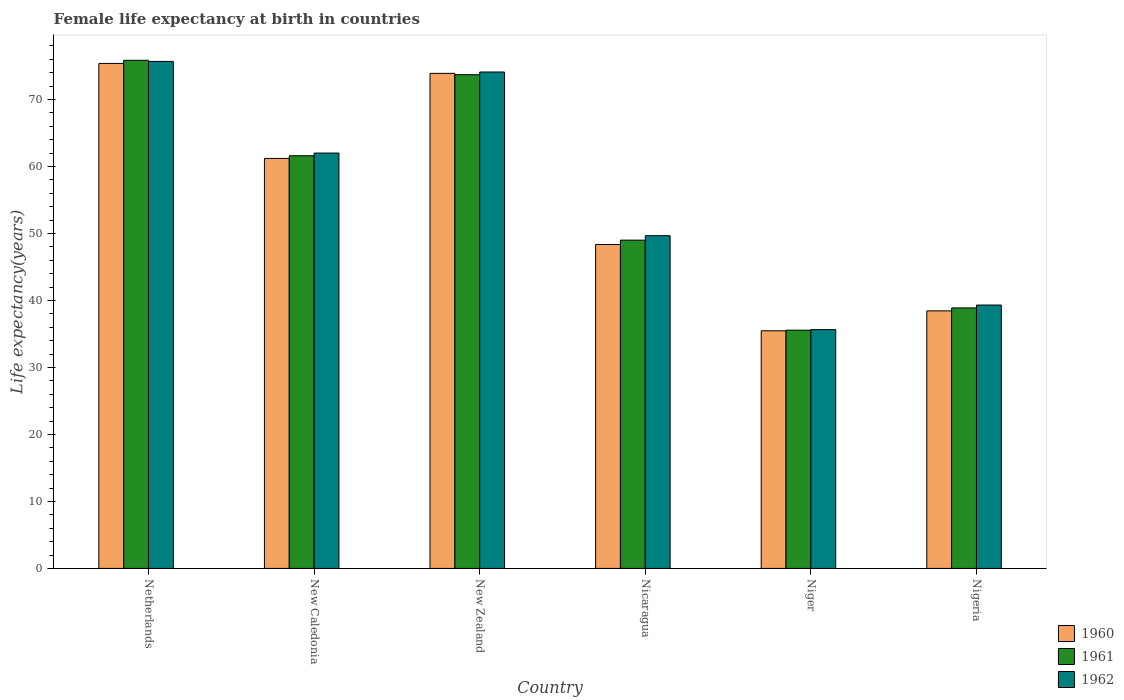How many different coloured bars are there?
Keep it short and to the point. 3. How many groups of bars are there?
Your answer should be compact. 6. How many bars are there on the 6th tick from the right?
Provide a short and direct response. 3. What is the label of the 3rd group of bars from the left?
Provide a succinct answer. New Zealand. What is the female life expectancy at birth in 1960 in Netherlands?
Your answer should be very brief. 75.38. Across all countries, what is the maximum female life expectancy at birth in 1960?
Your answer should be very brief. 75.38. Across all countries, what is the minimum female life expectancy at birth in 1962?
Offer a very short reply. 35.65. In which country was the female life expectancy at birth in 1961 minimum?
Your answer should be very brief. Niger. What is the total female life expectancy at birth in 1962 in the graph?
Offer a terse response. 336.41. What is the difference between the female life expectancy at birth in 1961 in Niger and that in Nigeria?
Provide a succinct answer. -3.33. What is the difference between the female life expectancy at birth in 1961 in Netherlands and the female life expectancy at birth in 1962 in New Caledonia?
Your response must be concise. 13.85. What is the average female life expectancy at birth in 1960 per country?
Your answer should be compact. 55.46. What is the difference between the female life expectancy at birth of/in 1961 and female life expectancy at birth of/in 1960 in New Caledonia?
Your response must be concise. 0.4. In how many countries, is the female life expectancy at birth in 1962 greater than 6 years?
Offer a very short reply. 6. What is the ratio of the female life expectancy at birth in 1962 in Netherlands to that in Nicaragua?
Provide a succinct answer. 1.52. Is the female life expectancy at birth in 1961 in Netherlands less than that in Niger?
Keep it short and to the point. No. Is the difference between the female life expectancy at birth in 1961 in New Zealand and Nigeria greater than the difference between the female life expectancy at birth in 1960 in New Zealand and Nigeria?
Your answer should be very brief. No. What is the difference between the highest and the second highest female life expectancy at birth in 1962?
Provide a succinct answer. -1.58. What is the difference between the highest and the lowest female life expectancy at birth in 1962?
Make the answer very short. 40.03. What does the 2nd bar from the left in Nigeria represents?
Your answer should be very brief. 1961. What does the 1st bar from the right in New Zealand represents?
Provide a succinct answer. 1962. Is it the case that in every country, the sum of the female life expectancy at birth in 1961 and female life expectancy at birth in 1960 is greater than the female life expectancy at birth in 1962?
Provide a succinct answer. Yes. Are all the bars in the graph horizontal?
Your answer should be very brief. No. How many countries are there in the graph?
Offer a very short reply. 6. Are the values on the major ticks of Y-axis written in scientific E-notation?
Keep it short and to the point. No. Does the graph contain any zero values?
Keep it short and to the point. No. How many legend labels are there?
Your answer should be compact. 3. How are the legend labels stacked?
Ensure brevity in your answer.  Vertical. What is the title of the graph?
Provide a short and direct response. Female life expectancy at birth in countries. Does "1989" appear as one of the legend labels in the graph?
Your response must be concise. No. What is the label or title of the Y-axis?
Offer a very short reply. Life expectancy(years). What is the Life expectancy(years) of 1960 in Netherlands?
Ensure brevity in your answer.  75.38. What is the Life expectancy(years) in 1961 in Netherlands?
Provide a succinct answer. 75.85. What is the Life expectancy(years) of 1962 in Netherlands?
Keep it short and to the point. 75.68. What is the Life expectancy(years) in 1960 in New Caledonia?
Your response must be concise. 61.2. What is the Life expectancy(years) of 1961 in New Caledonia?
Your response must be concise. 61.6. What is the Life expectancy(years) in 1962 in New Caledonia?
Offer a very short reply. 62. What is the Life expectancy(years) in 1960 in New Zealand?
Keep it short and to the point. 73.9. What is the Life expectancy(years) in 1961 in New Zealand?
Your answer should be compact. 73.7. What is the Life expectancy(years) of 1962 in New Zealand?
Offer a very short reply. 74.1. What is the Life expectancy(years) in 1960 in Nicaragua?
Your answer should be very brief. 48.35. What is the Life expectancy(years) of 1961 in Nicaragua?
Offer a terse response. 49. What is the Life expectancy(years) in 1962 in Nicaragua?
Ensure brevity in your answer.  49.67. What is the Life expectancy(years) of 1960 in Niger?
Provide a short and direct response. 35.47. What is the Life expectancy(years) in 1961 in Niger?
Offer a very short reply. 35.56. What is the Life expectancy(years) in 1962 in Niger?
Offer a terse response. 35.65. What is the Life expectancy(years) in 1960 in Nigeria?
Offer a very short reply. 38.45. What is the Life expectancy(years) of 1961 in Nigeria?
Your response must be concise. 38.89. What is the Life expectancy(years) in 1962 in Nigeria?
Offer a very short reply. 39.31. Across all countries, what is the maximum Life expectancy(years) of 1960?
Provide a succinct answer. 75.38. Across all countries, what is the maximum Life expectancy(years) in 1961?
Your response must be concise. 75.85. Across all countries, what is the maximum Life expectancy(years) of 1962?
Offer a terse response. 75.68. Across all countries, what is the minimum Life expectancy(years) in 1960?
Keep it short and to the point. 35.47. Across all countries, what is the minimum Life expectancy(years) in 1961?
Make the answer very short. 35.56. Across all countries, what is the minimum Life expectancy(years) in 1962?
Your response must be concise. 35.65. What is the total Life expectancy(years) of 1960 in the graph?
Keep it short and to the point. 332.75. What is the total Life expectancy(years) in 1961 in the graph?
Your answer should be very brief. 334.6. What is the total Life expectancy(years) of 1962 in the graph?
Provide a short and direct response. 336.41. What is the difference between the Life expectancy(years) of 1960 in Netherlands and that in New Caledonia?
Your response must be concise. 14.18. What is the difference between the Life expectancy(years) in 1961 in Netherlands and that in New Caledonia?
Ensure brevity in your answer.  14.25. What is the difference between the Life expectancy(years) of 1962 in Netherlands and that in New Caledonia?
Provide a succinct answer. 13.68. What is the difference between the Life expectancy(years) in 1960 in Netherlands and that in New Zealand?
Give a very brief answer. 1.48. What is the difference between the Life expectancy(years) of 1961 in Netherlands and that in New Zealand?
Offer a terse response. 2.15. What is the difference between the Life expectancy(years) of 1962 in Netherlands and that in New Zealand?
Your answer should be compact. 1.58. What is the difference between the Life expectancy(years) in 1960 in Netherlands and that in Nicaragua?
Offer a very short reply. 27.03. What is the difference between the Life expectancy(years) in 1961 in Netherlands and that in Nicaragua?
Keep it short and to the point. 26.85. What is the difference between the Life expectancy(years) in 1962 in Netherlands and that in Nicaragua?
Provide a succinct answer. 26.01. What is the difference between the Life expectancy(years) in 1960 in Netherlands and that in Niger?
Keep it short and to the point. 39.91. What is the difference between the Life expectancy(years) of 1961 in Netherlands and that in Niger?
Keep it short and to the point. 40.29. What is the difference between the Life expectancy(years) in 1962 in Netherlands and that in Niger?
Keep it short and to the point. 40.03. What is the difference between the Life expectancy(years) of 1960 in Netherlands and that in Nigeria?
Keep it short and to the point. 36.94. What is the difference between the Life expectancy(years) of 1961 in Netherlands and that in Nigeria?
Your answer should be very brief. 36.96. What is the difference between the Life expectancy(years) in 1962 in Netherlands and that in Nigeria?
Give a very brief answer. 36.37. What is the difference between the Life expectancy(years) in 1961 in New Caledonia and that in New Zealand?
Make the answer very short. -12.1. What is the difference between the Life expectancy(years) in 1962 in New Caledonia and that in New Zealand?
Your answer should be compact. -12.1. What is the difference between the Life expectancy(years) of 1960 in New Caledonia and that in Nicaragua?
Make the answer very short. 12.85. What is the difference between the Life expectancy(years) of 1961 in New Caledonia and that in Nicaragua?
Offer a very short reply. 12.6. What is the difference between the Life expectancy(years) of 1962 in New Caledonia and that in Nicaragua?
Your answer should be very brief. 12.33. What is the difference between the Life expectancy(years) of 1960 in New Caledonia and that in Niger?
Offer a very short reply. 25.73. What is the difference between the Life expectancy(years) in 1961 in New Caledonia and that in Niger?
Make the answer very short. 26.04. What is the difference between the Life expectancy(years) in 1962 in New Caledonia and that in Niger?
Provide a short and direct response. 26.35. What is the difference between the Life expectancy(years) in 1960 in New Caledonia and that in Nigeria?
Provide a short and direct response. 22.75. What is the difference between the Life expectancy(years) in 1961 in New Caledonia and that in Nigeria?
Provide a succinct answer. 22.71. What is the difference between the Life expectancy(years) of 1962 in New Caledonia and that in Nigeria?
Make the answer very short. 22.68. What is the difference between the Life expectancy(years) in 1960 in New Zealand and that in Nicaragua?
Provide a succinct answer. 25.55. What is the difference between the Life expectancy(years) in 1961 in New Zealand and that in Nicaragua?
Your answer should be very brief. 24.7. What is the difference between the Life expectancy(years) in 1962 in New Zealand and that in Nicaragua?
Your answer should be compact. 24.43. What is the difference between the Life expectancy(years) in 1960 in New Zealand and that in Niger?
Your response must be concise. 38.43. What is the difference between the Life expectancy(years) in 1961 in New Zealand and that in Niger?
Ensure brevity in your answer.  38.14. What is the difference between the Life expectancy(years) of 1962 in New Zealand and that in Niger?
Offer a very short reply. 38.45. What is the difference between the Life expectancy(years) in 1960 in New Zealand and that in Nigeria?
Keep it short and to the point. 35.45. What is the difference between the Life expectancy(years) in 1961 in New Zealand and that in Nigeria?
Your response must be concise. 34.81. What is the difference between the Life expectancy(years) in 1962 in New Zealand and that in Nigeria?
Provide a short and direct response. 34.78. What is the difference between the Life expectancy(years) in 1960 in Nicaragua and that in Niger?
Offer a terse response. 12.88. What is the difference between the Life expectancy(years) in 1961 in Nicaragua and that in Niger?
Provide a succinct answer. 13.44. What is the difference between the Life expectancy(years) of 1962 in Nicaragua and that in Niger?
Make the answer very short. 14.02. What is the difference between the Life expectancy(years) in 1960 in Nicaragua and that in Nigeria?
Your answer should be compact. 9.9. What is the difference between the Life expectancy(years) in 1961 in Nicaragua and that in Nigeria?
Ensure brevity in your answer.  10.12. What is the difference between the Life expectancy(years) in 1962 in Nicaragua and that in Nigeria?
Offer a very short reply. 10.35. What is the difference between the Life expectancy(years) of 1960 in Niger and that in Nigeria?
Your answer should be compact. -2.97. What is the difference between the Life expectancy(years) of 1961 in Niger and that in Nigeria?
Offer a terse response. -3.33. What is the difference between the Life expectancy(years) of 1962 in Niger and that in Nigeria?
Your response must be concise. -3.67. What is the difference between the Life expectancy(years) in 1960 in Netherlands and the Life expectancy(years) in 1961 in New Caledonia?
Keep it short and to the point. 13.78. What is the difference between the Life expectancy(years) of 1960 in Netherlands and the Life expectancy(years) of 1962 in New Caledonia?
Provide a succinct answer. 13.38. What is the difference between the Life expectancy(years) in 1961 in Netherlands and the Life expectancy(years) in 1962 in New Caledonia?
Give a very brief answer. 13.85. What is the difference between the Life expectancy(years) in 1960 in Netherlands and the Life expectancy(years) in 1961 in New Zealand?
Your response must be concise. 1.68. What is the difference between the Life expectancy(years) in 1960 in Netherlands and the Life expectancy(years) in 1962 in New Zealand?
Make the answer very short. 1.28. What is the difference between the Life expectancy(years) of 1961 in Netherlands and the Life expectancy(years) of 1962 in New Zealand?
Make the answer very short. 1.75. What is the difference between the Life expectancy(years) of 1960 in Netherlands and the Life expectancy(years) of 1961 in Nicaragua?
Keep it short and to the point. 26.38. What is the difference between the Life expectancy(years) in 1960 in Netherlands and the Life expectancy(years) in 1962 in Nicaragua?
Your response must be concise. 25.71. What is the difference between the Life expectancy(years) in 1961 in Netherlands and the Life expectancy(years) in 1962 in Nicaragua?
Your answer should be compact. 26.18. What is the difference between the Life expectancy(years) in 1960 in Netherlands and the Life expectancy(years) in 1961 in Niger?
Keep it short and to the point. 39.82. What is the difference between the Life expectancy(years) in 1960 in Netherlands and the Life expectancy(years) in 1962 in Niger?
Your response must be concise. 39.73. What is the difference between the Life expectancy(years) of 1961 in Netherlands and the Life expectancy(years) of 1962 in Niger?
Your answer should be compact. 40.2. What is the difference between the Life expectancy(years) in 1960 in Netherlands and the Life expectancy(years) in 1961 in Nigeria?
Make the answer very short. 36.49. What is the difference between the Life expectancy(years) of 1960 in Netherlands and the Life expectancy(years) of 1962 in Nigeria?
Ensure brevity in your answer.  36.06. What is the difference between the Life expectancy(years) of 1961 in Netherlands and the Life expectancy(years) of 1962 in Nigeria?
Your answer should be compact. 36.53. What is the difference between the Life expectancy(years) in 1960 in New Caledonia and the Life expectancy(years) in 1961 in New Zealand?
Give a very brief answer. -12.5. What is the difference between the Life expectancy(years) of 1961 in New Caledonia and the Life expectancy(years) of 1962 in New Zealand?
Provide a short and direct response. -12.5. What is the difference between the Life expectancy(years) of 1960 in New Caledonia and the Life expectancy(years) of 1961 in Nicaragua?
Your answer should be very brief. 12.2. What is the difference between the Life expectancy(years) of 1960 in New Caledonia and the Life expectancy(years) of 1962 in Nicaragua?
Ensure brevity in your answer.  11.53. What is the difference between the Life expectancy(years) of 1961 in New Caledonia and the Life expectancy(years) of 1962 in Nicaragua?
Provide a succinct answer. 11.93. What is the difference between the Life expectancy(years) of 1960 in New Caledonia and the Life expectancy(years) of 1961 in Niger?
Give a very brief answer. 25.64. What is the difference between the Life expectancy(years) in 1960 in New Caledonia and the Life expectancy(years) in 1962 in Niger?
Give a very brief answer. 25.55. What is the difference between the Life expectancy(years) of 1961 in New Caledonia and the Life expectancy(years) of 1962 in Niger?
Ensure brevity in your answer.  25.95. What is the difference between the Life expectancy(years) of 1960 in New Caledonia and the Life expectancy(years) of 1961 in Nigeria?
Offer a very short reply. 22.31. What is the difference between the Life expectancy(years) in 1960 in New Caledonia and the Life expectancy(years) in 1962 in Nigeria?
Make the answer very short. 21.89. What is the difference between the Life expectancy(years) in 1961 in New Caledonia and the Life expectancy(years) in 1962 in Nigeria?
Provide a succinct answer. 22.29. What is the difference between the Life expectancy(years) of 1960 in New Zealand and the Life expectancy(years) of 1961 in Nicaragua?
Make the answer very short. 24.9. What is the difference between the Life expectancy(years) of 1960 in New Zealand and the Life expectancy(years) of 1962 in Nicaragua?
Ensure brevity in your answer.  24.23. What is the difference between the Life expectancy(years) in 1961 in New Zealand and the Life expectancy(years) in 1962 in Nicaragua?
Ensure brevity in your answer.  24.03. What is the difference between the Life expectancy(years) in 1960 in New Zealand and the Life expectancy(years) in 1961 in Niger?
Provide a succinct answer. 38.34. What is the difference between the Life expectancy(years) of 1960 in New Zealand and the Life expectancy(years) of 1962 in Niger?
Provide a short and direct response. 38.25. What is the difference between the Life expectancy(years) in 1961 in New Zealand and the Life expectancy(years) in 1962 in Niger?
Offer a very short reply. 38.05. What is the difference between the Life expectancy(years) in 1960 in New Zealand and the Life expectancy(years) in 1961 in Nigeria?
Keep it short and to the point. 35.01. What is the difference between the Life expectancy(years) in 1960 in New Zealand and the Life expectancy(years) in 1962 in Nigeria?
Your answer should be compact. 34.59. What is the difference between the Life expectancy(years) of 1961 in New Zealand and the Life expectancy(years) of 1962 in Nigeria?
Offer a terse response. 34.38. What is the difference between the Life expectancy(years) of 1960 in Nicaragua and the Life expectancy(years) of 1961 in Niger?
Offer a terse response. 12.79. What is the difference between the Life expectancy(years) of 1960 in Nicaragua and the Life expectancy(years) of 1962 in Niger?
Make the answer very short. 12.7. What is the difference between the Life expectancy(years) in 1961 in Nicaragua and the Life expectancy(years) in 1962 in Niger?
Give a very brief answer. 13.36. What is the difference between the Life expectancy(years) of 1960 in Nicaragua and the Life expectancy(years) of 1961 in Nigeria?
Your response must be concise. 9.46. What is the difference between the Life expectancy(years) of 1960 in Nicaragua and the Life expectancy(years) of 1962 in Nigeria?
Provide a short and direct response. 9.04. What is the difference between the Life expectancy(years) in 1961 in Nicaragua and the Life expectancy(years) in 1962 in Nigeria?
Your answer should be very brief. 9.69. What is the difference between the Life expectancy(years) in 1960 in Niger and the Life expectancy(years) in 1961 in Nigeria?
Your response must be concise. -3.42. What is the difference between the Life expectancy(years) in 1960 in Niger and the Life expectancy(years) in 1962 in Nigeria?
Offer a terse response. -3.84. What is the difference between the Life expectancy(years) in 1961 in Niger and the Life expectancy(years) in 1962 in Nigeria?
Ensure brevity in your answer.  -3.75. What is the average Life expectancy(years) of 1960 per country?
Your answer should be compact. 55.46. What is the average Life expectancy(years) in 1961 per country?
Ensure brevity in your answer.  55.77. What is the average Life expectancy(years) of 1962 per country?
Your response must be concise. 56.07. What is the difference between the Life expectancy(years) of 1960 and Life expectancy(years) of 1961 in Netherlands?
Offer a terse response. -0.47. What is the difference between the Life expectancy(years) of 1960 and Life expectancy(years) of 1962 in Netherlands?
Offer a terse response. -0.3. What is the difference between the Life expectancy(years) of 1961 and Life expectancy(years) of 1962 in Netherlands?
Your answer should be compact. 0.17. What is the difference between the Life expectancy(years) of 1960 and Life expectancy(years) of 1961 in New Caledonia?
Ensure brevity in your answer.  -0.4. What is the difference between the Life expectancy(years) in 1960 and Life expectancy(years) in 1962 in New Zealand?
Offer a very short reply. -0.2. What is the difference between the Life expectancy(years) of 1960 and Life expectancy(years) of 1961 in Nicaragua?
Offer a terse response. -0.65. What is the difference between the Life expectancy(years) in 1960 and Life expectancy(years) in 1962 in Nicaragua?
Your response must be concise. -1.32. What is the difference between the Life expectancy(years) in 1961 and Life expectancy(years) in 1962 in Nicaragua?
Offer a very short reply. -0.66. What is the difference between the Life expectancy(years) in 1960 and Life expectancy(years) in 1961 in Niger?
Provide a short and direct response. -0.09. What is the difference between the Life expectancy(years) in 1960 and Life expectancy(years) in 1962 in Niger?
Provide a succinct answer. -0.17. What is the difference between the Life expectancy(years) of 1961 and Life expectancy(years) of 1962 in Niger?
Ensure brevity in your answer.  -0.08. What is the difference between the Life expectancy(years) in 1960 and Life expectancy(years) in 1961 in Nigeria?
Make the answer very short. -0.44. What is the difference between the Life expectancy(years) in 1960 and Life expectancy(years) in 1962 in Nigeria?
Your answer should be very brief. -0.87. What is the difference between the Life expectancy(years) of 1961 and Life expectancy(years) of 1962 in Nigeria?
Provide a short and direct response. -0.43. What is the ratio of the Life expectancy(years) of 1960 in Netherlands to that in New Caledonia?
Offer a very short reply. 1.23. What is the ratio of the Life expectancy(years) of 1961 in Netherlands to that in New Caledonia?
Provide a succinct answer. 1.23. What is the ratio of the Life expectancy(years) of 1962 in Netherlands to that in New Caledonia?
Your answer should be very brief. 1.22. What is the ratio of the Life expectancy(years) in 1961 in Netherlands to that in New Zealand?
Ensure brevity in your answer.  1.03. What is the ratio of the Life expectancy(years) in 1962 in Netherlands to that in New Zealand?
Offer a terse response. 1.02. What is the ratio of the Life expectancy(years) in 1960 in Netherlands to that in Nicaragua?
Provide a short and direct response. 1.56. What is the ratio of the Life expectancy(years) in 1961 in Netherlands to that in Nicaragua?
Make the answer very short. 1.55. What is the ratio of the Life expectancy(years) of 1962 in Netherlands to that in Nicaragua?
Make the answer very short. 1.52. What is the ratio of the Life expectancy(years) in 1960 in Netherlands to that in Niger?
Your answer should be compact. 2.13. What is the ratio of the Life expectancy(years) of 1961 in Netherlands to that in Niger?
Your answer should be very brief. 2.13. What is the ratio of the Life expectancy(years) of 1962 in Netherlands to that in Niger?
Offer a very short reply. 2.12. What is the ratio of the Life expectancy(years) in 1960 in Netherlands to that in Nigeria?
Your answer should be compact. 1.96. What is the ratio of the Life expectancy(years) of 1961 in Netherlands to that in Nigeria?
Offer a very short reply. 1.95. What is the ratio of the Life expectancy(years) of 1962 in Netherlands to that in Nigeria?
Give a very brief answer. 1.93. What is the ratio of the Life expectancy(years) of 1960 in New Caledonia to that in New Zealand?
Ensure brevity in your answer.  0.83. What is the ratio of the Life expectancy(years) in 1961 in New Caledonia to that in New Zealand?
Your answer should be compact. 0.84. What is the ratio of the Life expectancy(years) of 1962 in New Caledonia to that in New Zealand?
Provide a succinct answer. 0.84. What is the ratio of the Life expectancy(years) of 1960 in New Caledonia to that in Nicaragua?
Offer a very short reply. 1.27. What is the ratio of the Life expectancy(years) of 1961 in New Caledonia to that in Nicaragua?
Keep it short and to the point. 1.26. What is the ratio of the Life expectancy(years) in 1962 in New Caledonia to that in Nicaragua?
Give a very brief answer. 1.25. What is the ratio of the Life expectancy(years) in 1960 in New Caledonia to that in Niger?
Offer a very short reply. 1.73. What is the ratio of the Life expectancy(years) of 1961 in New Caledonia to that in Niger?
Your response must be concise. 1.73. What is the ratio of the Life expectancy(years) of 1962 in New Caledonia to that in Niger?
Give a very brief answer. 1.74. What is the ratio of the Life expectancy(years) of 1960 in New Caledonia to that in Nigeria?
Give a very brief answer. 1.59. What is the ratio of the Life expectancy(years) in 1961 in New Caledonia to that in Nigeria?
Your response must be concise. 1.58. What is the ratio of the Life expectancy(years) in 1962 in New Caledonia to that in Nigeria?
Provide a succinct answer. 1.58. What is the ratio of the Life expectancy(years) of 1960 in New Zealand to that in Nicaragua?
Provide a short and direct response. 1.53. What is the ratio of the Life expectancy(years) of 1961 in New Zealand to that in Nicaragua?
Your answer should be very brief. 1.5. What is the ratio of the Life expectancy(years) of 1962 in New Zealand to that in Nicaragua?
Offer a very short reply. 1.49. What is the ratio of the Life expectancy(years) in 1960 in New Zealand to that in Niger?
Provide a short and direct response. 2.08. What is the ratio of the Life expectancy(years) in 1961 in New Zealand to that in Niger?
Ensure brevity in your answer.  2.07. What is the ratio of the Life expectancy(years) of 1962 in New Zealand to that in Niger?
Your response must be concise. 2.08. What is the ratio of the Life expectancy(years) of 1960 in New Zealand to that in Nigeria?
Provide a succinct answer. 1.92. What is the ratio of the Life expectancy(years) in 1961 in New Zealand to that in Nigeria?
Your answer should be compact. 1.9. What is the ratio of the Life expectancy(years) in 1962 in New Zealand to that in Nigeria?
Provide a succinct answer. 1.88. What is the ratio of the Life expectancy(years) of 1960 in Nicaragua to that in Niger?
Offer a very short reply. 1.36. What is the ratio of the Life expectancy(years) of 1961 in Nicaragua to that in Niger?
Keep it short and to the point. 1.38. What is the ratio of the Life expectancy(years) in 1962 in Nicaragua to that in Niger?
Make the answer very short. 1.39. What is the ratio of the Life expectancy(years) of 1960 in Nicaragua to that in Nigeria?
Provide a short and direct response. 1.26. What is the ratio of the Life expectancy(years) in 1961 in Nicaragua to that in Nigeria?
Your answer should be compact. 1.26. What is the ratio of the Life expectancy(years) of 1962 in Nicaragua to that in Nigeria?
Your answer should be very brief. 1.26. What is the ratio of the Life expectancy(years) of 1960 in Niger to that in Nigeria?
Offer a very short reply. 0.92. What is the ratio of the Life expectancy(years) in 1961 in Niger to that in Nigeria?
Ensure brevity in your answer.  0.91. What is the ratio of the Life expectancy(years) in 1962 in Niger to that in Nigeria?
Make the answer very short. 0.91. What is the difference between the highest and the second highest Life expectancy(years) in 1960?
Offer a terse response. 1.48. What is the difference between the highest and the second highest Life expectancy(years) of 1961?
Give a very brief answer. 2.15. What is the difference between the highest and the second highest Life expectancy(years) of 1962?
Provide a short and direct response. 1.58. What is the difference between the highest and the lowest Life expectancy(years) in 1960?
Provide a short and direct response. 39.91. What is the difference between the highest and the lowest Life expectancy(years) of 1961?
Provide a short and direct response. 40.29. What is the difference between the highest and the lowest Life expectancy(years) in 1962?
Make the answer very short. 40.03. 